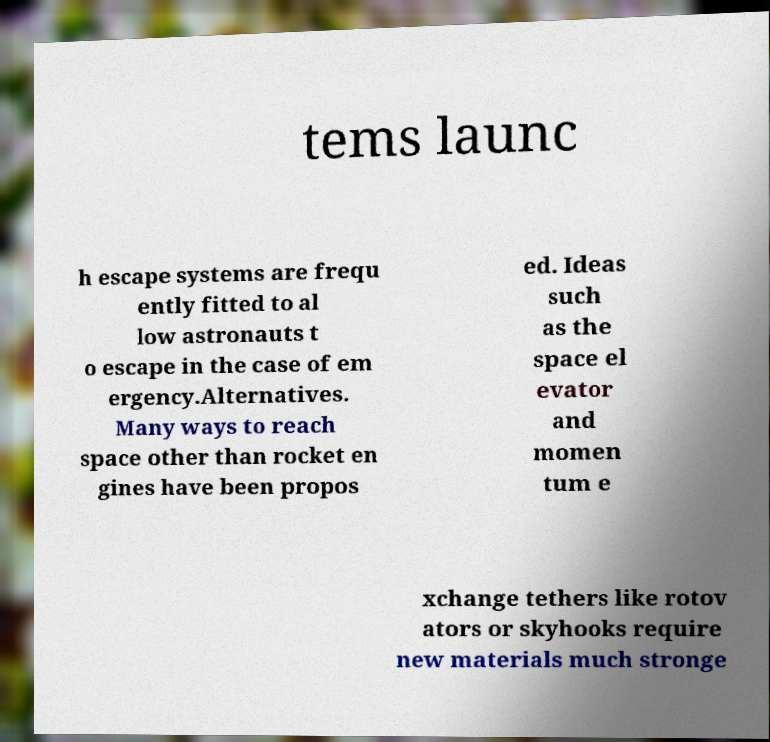Can you accurately transcribe the text from the provided image for me? tems launc h escape systems are frequ ently fitted to al low astronauts t o escape in the case of em ergency.Alternatives. Many ways to reach space other than rocket en gines have been propos ed. Ideas such as the space el evator and momen tum e xchange tethers like rotov ators or skyhooks require new materials much stronge 